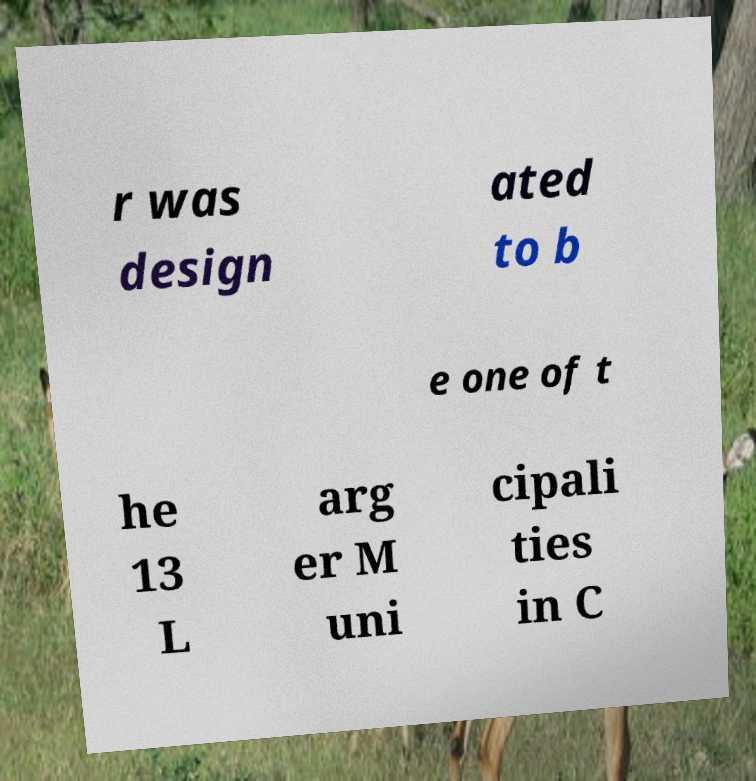There's text embedded in this image that I need extracted. Can you transcribe it verbatim? r was design ated to b e one of t he 13 L arg er M uni cipali ties in C 